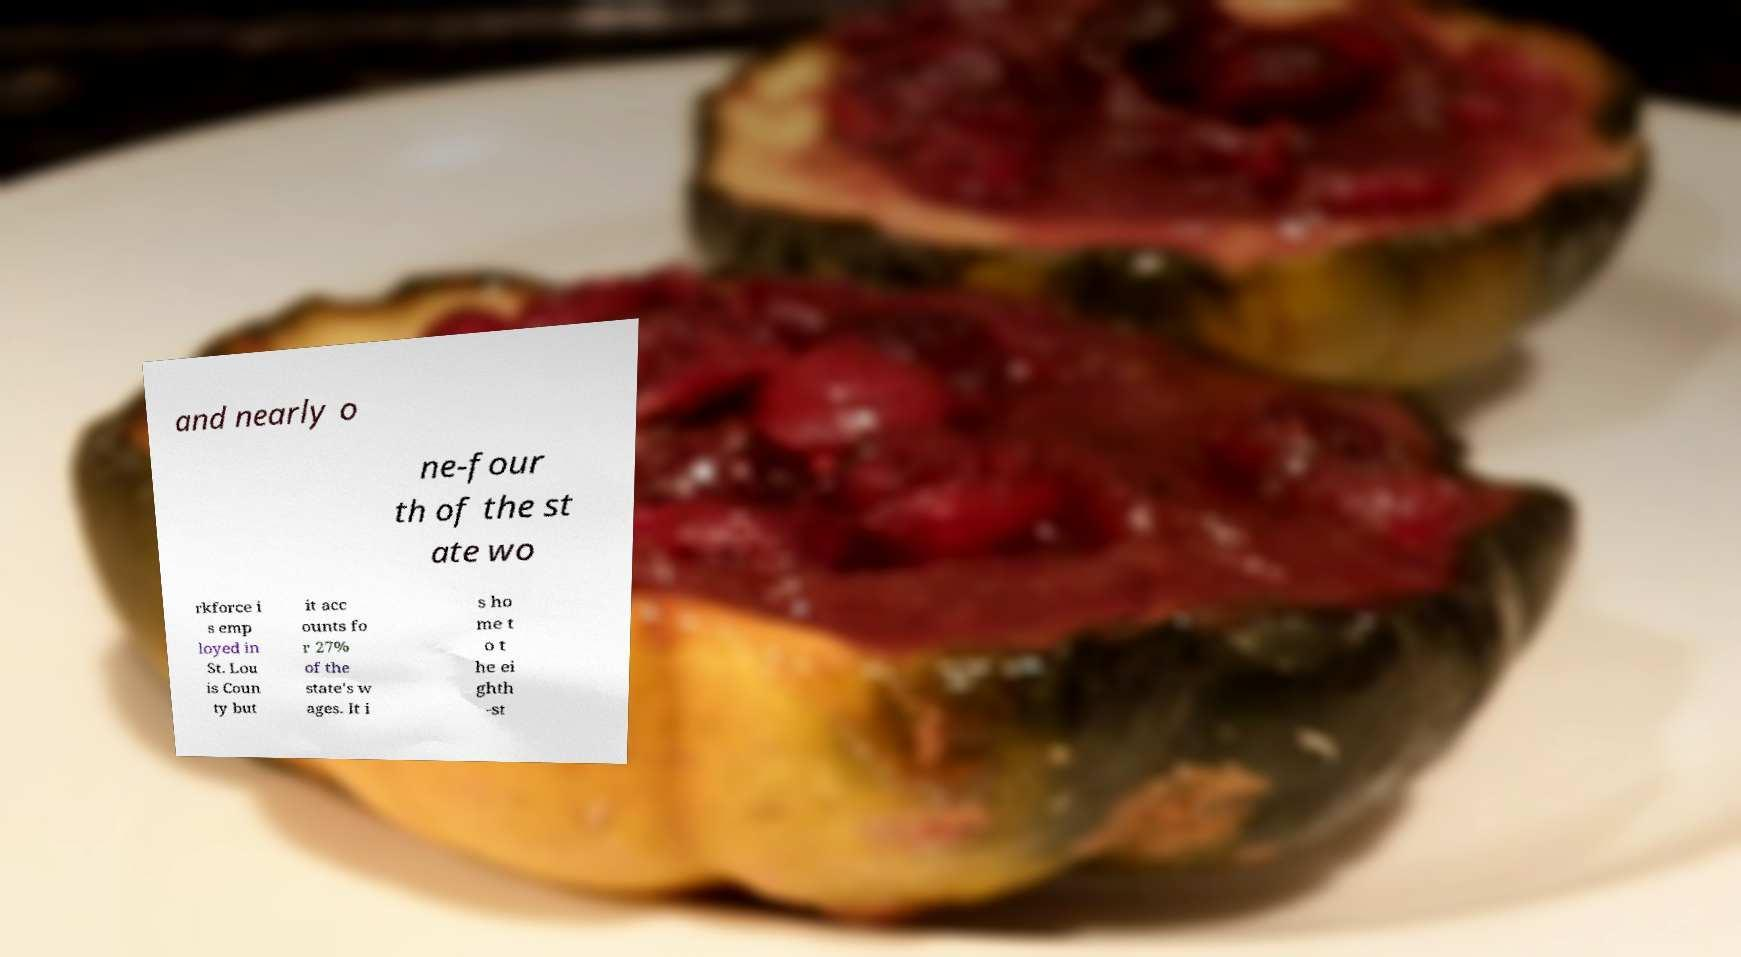What messages or text are displayed in this image? I need them in a readable, typed format. and nearly o ne-four th of the st ate wo rkforce i s emp loyed in St. Lou is Coun ty but it acc ounts fo r 27% of the state's w ages. It i s ho me t o t he ei ghth -st 